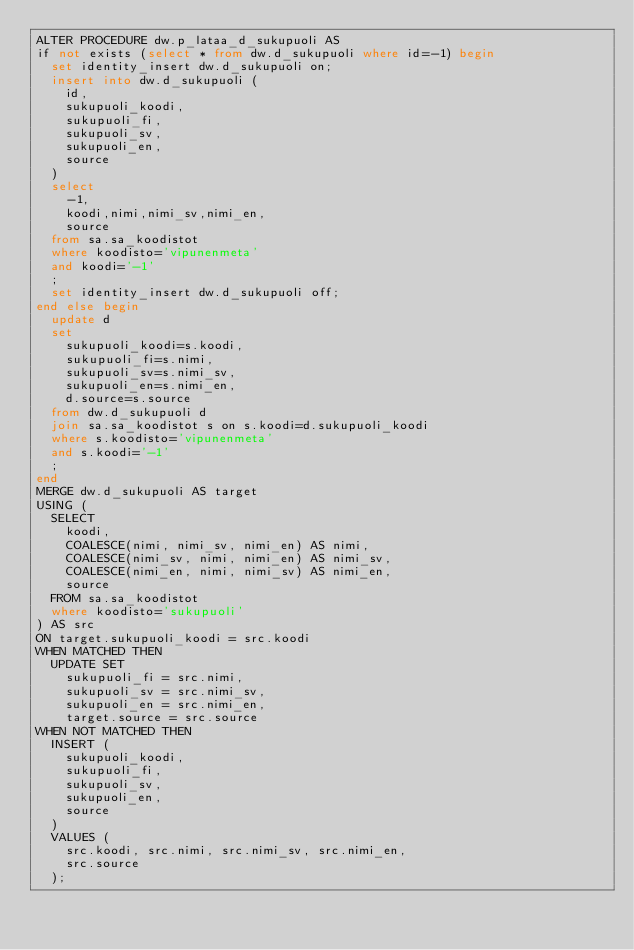Convert code to text. <code><loc_0><loc_0><loc_500><loc_500><_SQL_>ALTER PROCEDURE dw.p_lataa_d_sukupuoli AS
if not exists (select * from dw.d_sukupuoli where id=-1) begin
  set identity_insert dw.d_sukupuoli on;
  insert into dw.d_sukupuoli (
    id,
    sukupuoli_koodi,
    sukupuoli_fi,
    sukupuoli_sv,
    sukupuoli_en,
    source
  )
  select
    -1,
    koodi,nimi,nimi_sv,nimi_en,
    source
  from sa.sa_koodistot
  where koodisto='vipunenmeta'
  and koodi='-1'
  ;
  set identity_insert dw.d_sukupuoli off;
end else begin
  update d
  set
    sukupuoli_koodi=s.koodi,
    sukupuoli_fi=s.nimi,
    sukupuoli_sv=s.nimi_sv,
    sukupuoli_en=s.nimi_en,
    d.source=s.source
  from dw.d_sukupuoli d
  join sa.sa_koodistot s on s.koodi=d.sukupuoli_koodi
  where s.koodisto='vipunenmeta'
  and s.koodi='-1'
  ;
end
MERGE dw.d_sukupuoli AS target
USING (
  SELECT
    koodi,
    COALESCE(nimi, nimi_sv, nimi_en) AS nimi,
    COALESCE(nimi_sv, nimi, nimi_en) AS nimi_sv,
    COALESCE(nimi_en, nimi, nimi_sv) AS nimi_en,
    source
  FROM sa.sa_koodistot
  where koodisto='sukupuoli'
) AS src
ON target.sukupuoli_koodi = src.koodi
WHEN MATCHED THEN
  UPDATE SET
    sukupuoli_fi = src.nimi,
    sukupuoli_sv = src.nimi_sv,
    sukupuoli_en = src.nimi_en,
    target.source = src.source
WHEN NOT MATCHED THEN
  INSERT (
    sukupuoli_koodi,
    sukupuoli_fi,
    sukupuoli_sv,
    sukupuoli_en,
    source
  )
  VALUES (
    src.koodi, src.nimi, src.nimi_sv, src.nimi_en,
    src.source
  );
</code> 